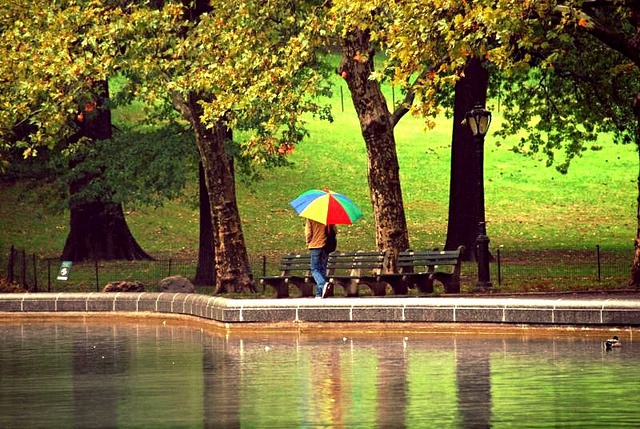Describe the objects in this image and their specific colors. I can see bench in olive, black, gray, and maroon tones, bench in olive, black, gray, and darkgreen tones, umbrella in olive, yellow, red, and lightblue tones, people in olive, black, brown, maroon, and orange tones, and people in olive, black, maroon, and brown tones in this image. 